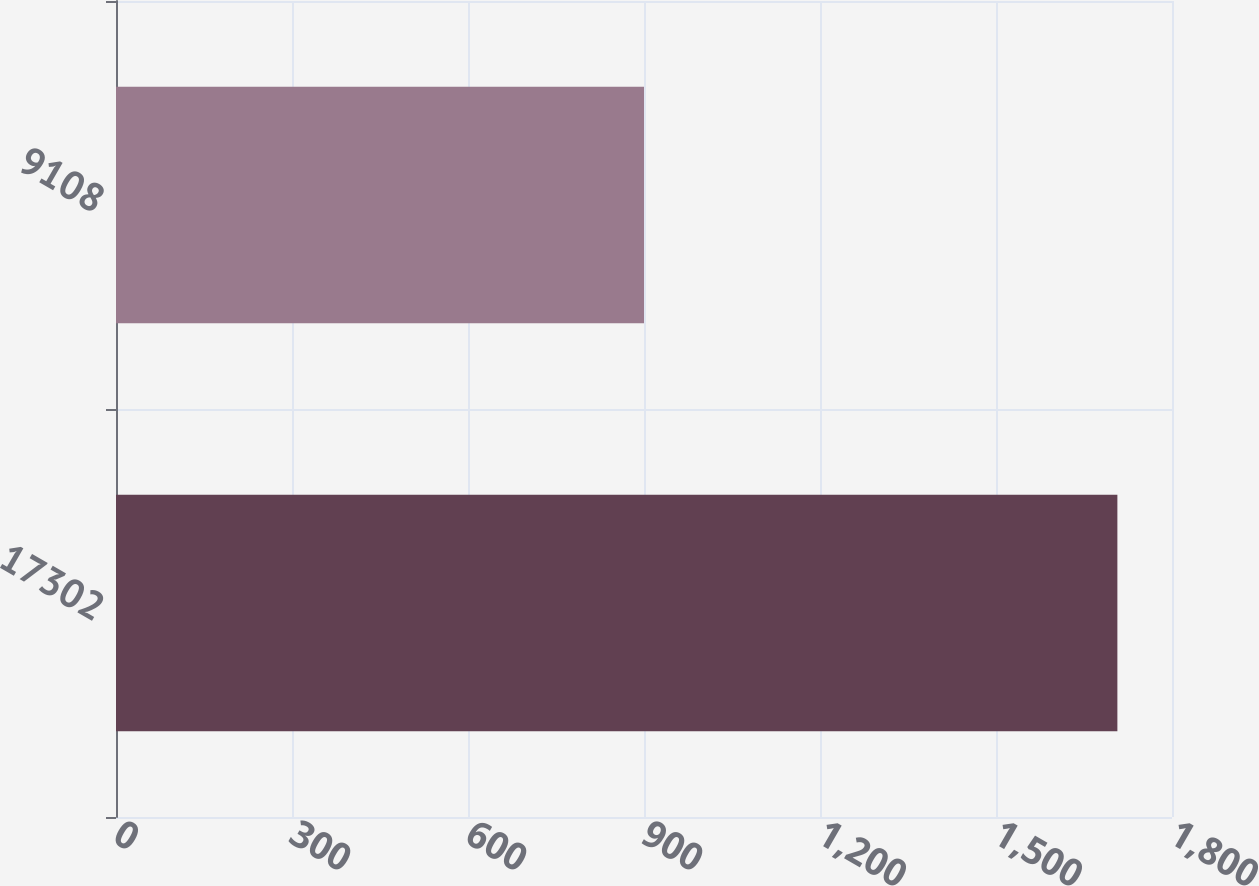Convert chart to OTSL. <chart><loc_0><loc_0><loc_500><loc_500><bar_chart><fcel>17302<fcel>9108<nl><fcel>1706.9<fcel>900<nl></chart> 